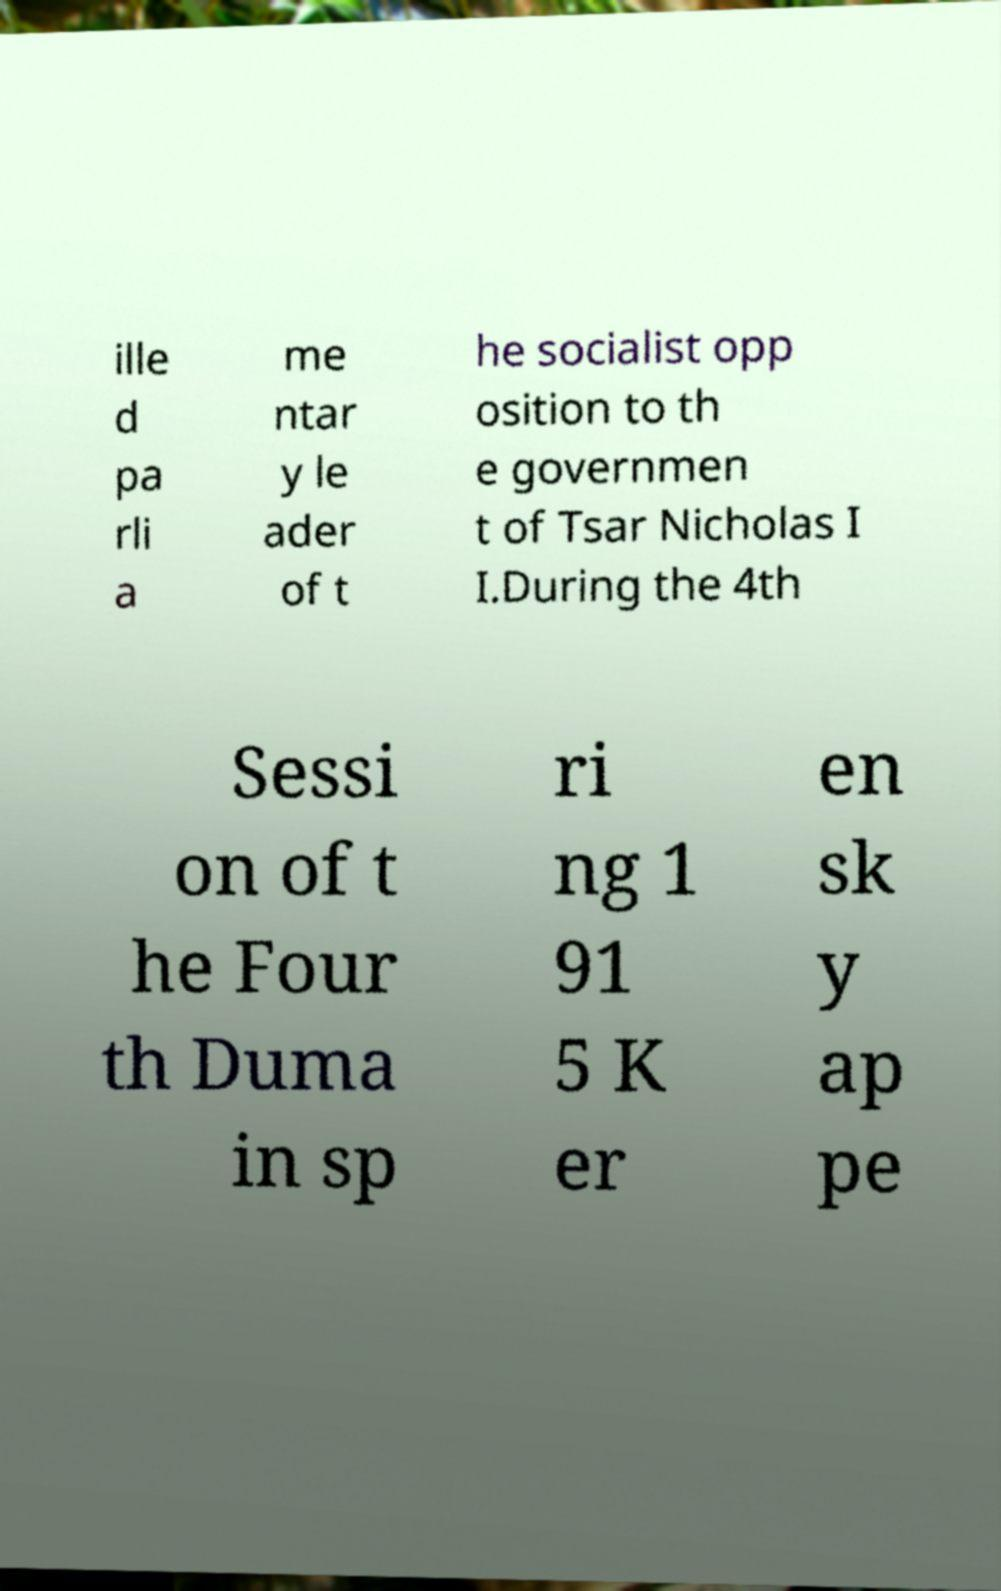Please read and relay the text visible in this image. What does it say? ille d pa rli a me ntar y le ader of t he socialist opp osition to th e governmen t of Tsar Nicholas I I.During the 4th Sessi on of t he Four th Duma in sp ri ng 1 91 5 K er en sk y ap pe 